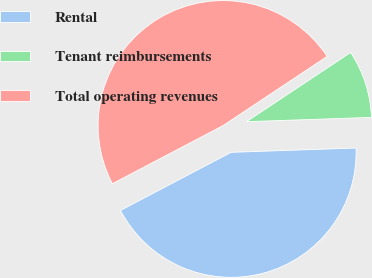<chart> <loc_0><loc_0><loc_500><loc_500><pie_chart><fcel>Rental<fcel>Tenant reimbursements<fcel>Total operating revenues<nl><fcel>42.85%<fcel>8.79%<fcel>48.36%<nl></chart> 